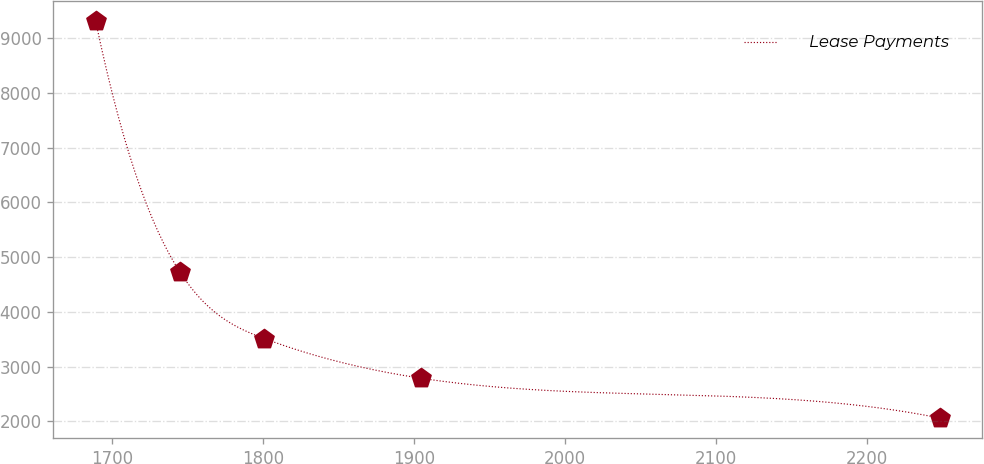Convert chart. <chart><loc_0><loc_0><loc_500><loc_500><line_chart><ecel><fcel>Lease Payments<nl><fcel>1689.22<fcel>9312.82<nl><fcel>1745.11<fcel>4724.67<nl><fcel>1801<fcel>3511.42<nl><fcel>1904.98<fcel>2786.24<nl><fcel>2248.15<fcel>2061.06<nl></chart> 